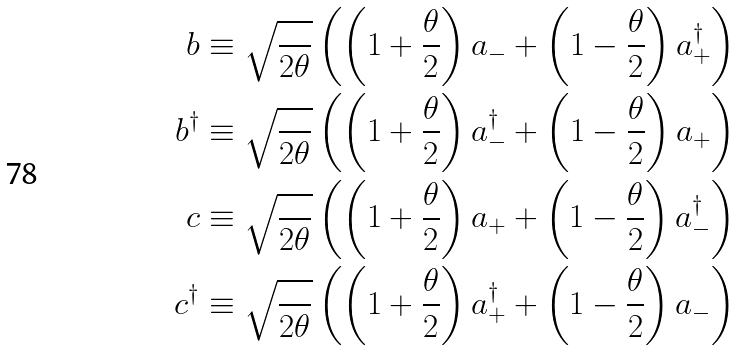Convert formula to latex. <formula><loc_0><loc_0><loc_500><loc_500>b & \equiv \sqrt { \frac { } { 2 \theta } } \left ( \left ( 1 + \frac { \theta } { 2 } \right ) a _ { - } + \left ( 1 - \frac { \theta } { 2 } \right ) a _ { + } ^ { \dagger } \right ) \\ b ^ { \dagger } & \equiv \sqrt { \frac { } { 2 \theta } } \left ( \left ( 1 + \frac { \theta } { 2 } \right ) a _ { - } ^ { \dagger } + \left ( 1 - \frac { \theta } { 2 } \right ) a _ { + } \right ) \\ c & \equiv \sqrt { \frac { } { 2 \theta } } \left ( \left ( 1 + \frac { \theta } { 2 } \right ) a _ { + } + \left ( 1 - \frac { \theta } { 2 } \right ) a _ { - } ^ { \dagger } \right ) \\ c ^ { \dagger } & \equiv \sqrt { \frac { } { 2 \theta } } \left ( \left ( 1 + \frac { \theta } { 2 } \right ) a _ { + } ^ { \dagger } + \left ( 1 - \frac { \theta } { 2 } \right ) a _ { - } \right )</formula> 